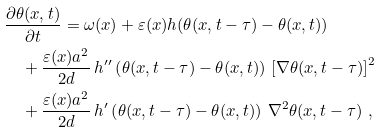<formula> <loc_0><loc_0><loc_500><loc_500>& \frac { \partial \theta ( { x } , t ) } { \partial t } = \omega ( { x } ) + \varepsilon ( { x } ) h ( \theta ( { x } , t - \tau ) - \theta ( { x } , t ) ) \\ & \quad + \frac { \varepsilon ( { x } ) a ^ { 2 } } { 2 d } \, h ^ { \prime \prime } \left ( \theta ( { x } , t - \tau ) - \theta ( { x } , t ) \right ) \, \left [ \nabla \theta ( { x } , t - \tau ) \right ] ^ { 2 } \\ & \quad + \frac { \varepsilon ( { x } ) a ^ { 2 } } { 2 d } \, h ^ { \prime } \left ( \theta ( { x } , t - \tau ) - \theta ( { x } , t ) \right ) \, \nabla ^ { 2 } \theta ( { x } , t - \tau ) \ ,</formula> 